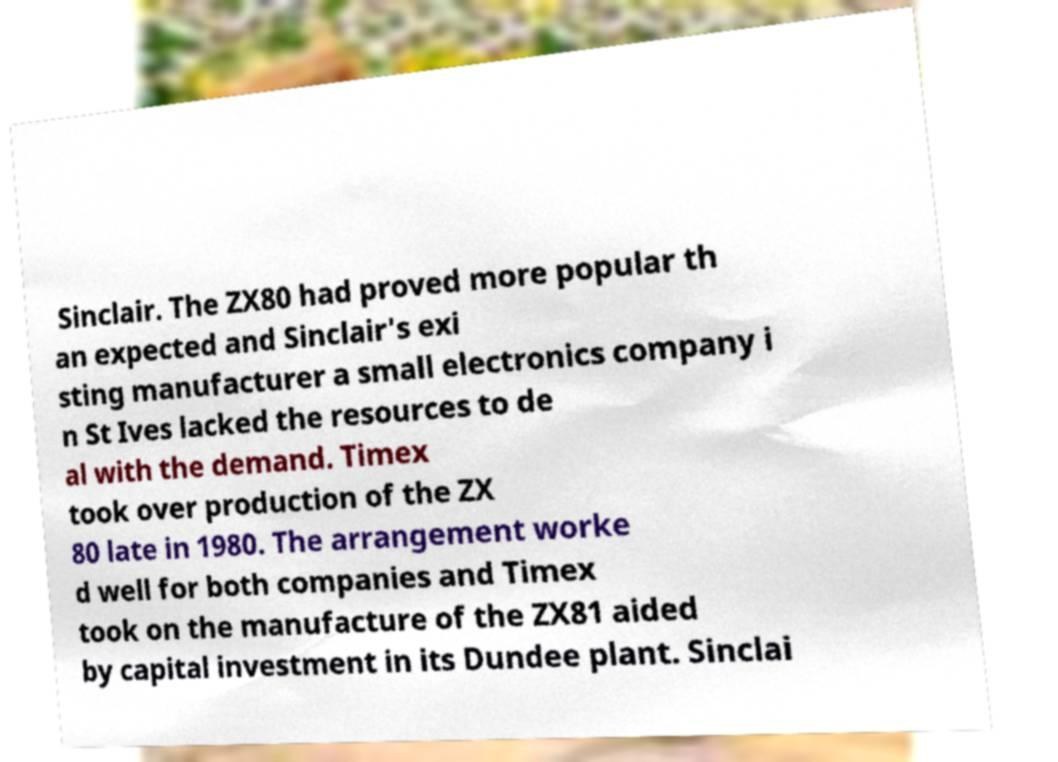Can you accurately transcribe the text from the provided image for me? Sinclair. The ZX80 had proved more popular th an expected and Sinclair's exi sting manufacturer a small electronics company i n St Ives lacked the resources to de al with the demand. Timex took over production of the ZX 80 late in 1980. The arrangement worke d well for both companies and Timex took on the manufacture of the ZX81 aided by capital investment in its Dundee plant. Sinclai 